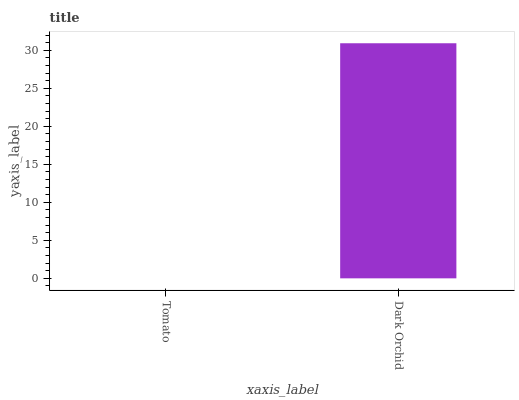Is Tomato the minimum?
Answer yes or no. Yes. Is Dark Orchid the maximum?
Answer yes or no. Yes. Is Dark Orchid the minimum?
Answer yes or no. No. Is Dark Orchid greater than Tomato?
Answer yes or no. Yes. Is Tomato less than Dark Orchid?
Answer yes or no. Yes. Is Tomato greater than Dark Orchid?
Answer yes or no. No. Is Dark Orchid less than Tomato?
Answer yes or no. No. Is Dark Orchid the high median?
Answer yes or no. Yes. Is Tomato the low median?
Answer yes or no. Yes. Is Tomato the high median?
Answer yes or no. No. Is Dark Orchid the low median?
Answer yes or no. No. 